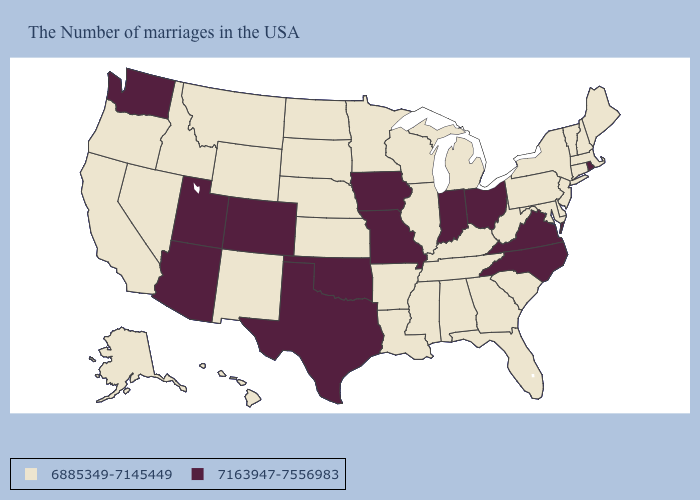Among the states that border Nevada , does Arizona have the lowest value?
Quick response, please. No. Among the states that border Arizona , does Colorado have the highest value?
Keep it brief. Yes. Among the states that border Virginia , does North Carolina have the highest value?
Short answer required. Yes. Does Indiana have the lowest value in the USA?
Give a very brief answer. No. What is the highest value in the USA?
Short answer required. 7163947-7556983. Does Rhode Island have the same value as Maryland?
Keep it brief. No. What is the value of West Virginia?
Concise answer only. 6885349-7145449. What is the highest value in the South ?
Concise answer only. 7163947-7556983. What is the value of Oklahoma?
Give a very brief answer. 7163947-7556983. What is the value of Nevada?
Write a very short answer. 6885349-7145449. What is the value of Rhode Island?
Give a very brief answer. 7163947-7556983. Name the states that have a value in the range 6885349-7145449?
Quick response, please. Maine, Massachusetts, New Hampshire, Vermont, Connecticut, New York, New Jersey, Delaware, Maryland, Pennsylvania, South Carolina, West Virginia, Florida, Georgia, Michigan, Kentucky, Alabama, Tennessee, Wisconsin, Illinois, Mississippi, Louisiana, Arkansas, Minnesota, Kansas, Nebraska, South Dakota, North Dakota, Wyoming, New Mexico, Montana, Idaho, Nevada, California, Oregon, Alaska, Hawaii. What is the value of Maryland?
Answer briefly. 6885349-7145449. Does Virginia have the lowest value in the South?
Answer briefly. No. What is the value of Utah?
Short answer required. 7163947-7556983. 